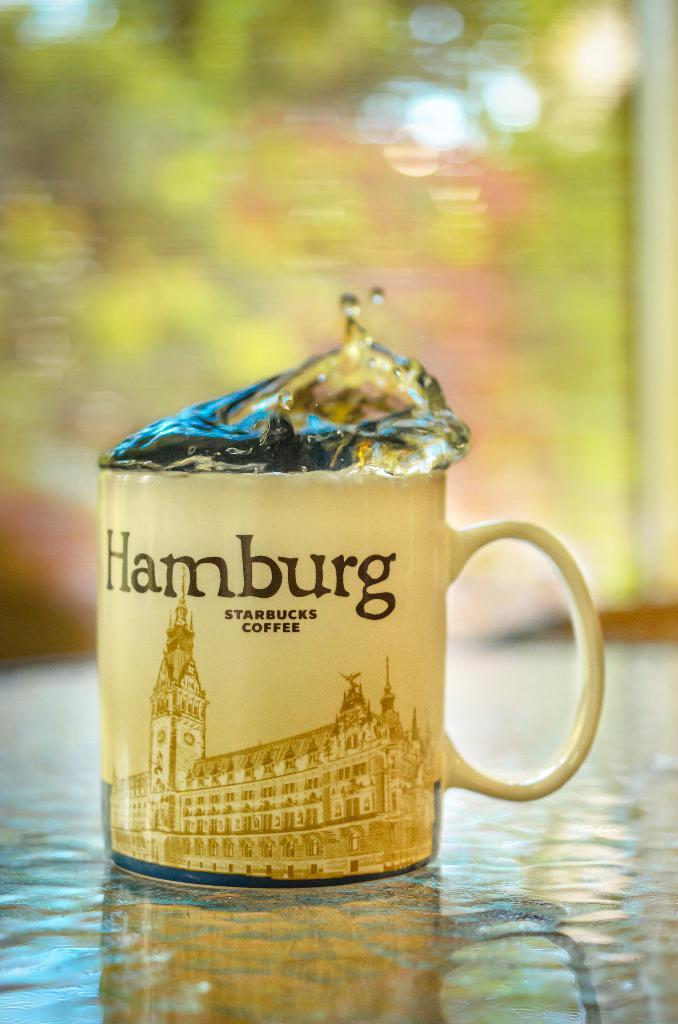<image>
Share a concise interpretation of the image provided. A mug with "Hamburg" written on it and some liquid coming out. 